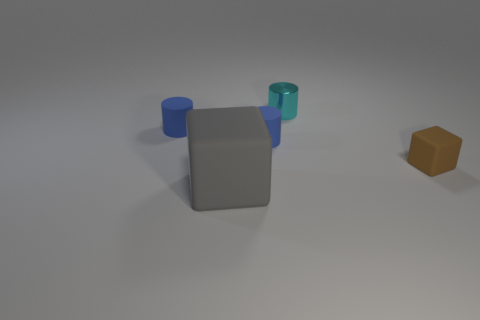Are there any blue cylinders that have the same size as the brown object?
Ensure brevity in your answer.  Yes. There is a object on the left side of the big gray object; is its color the same as the rubber cylinder that is on the right side of the gray matte object?
Keep it short and to the point. Yes. What number of matte objects are small brown spheres or tiny blue cylinders?
Offer a terse response. 2. There is a block that is left of the blue matte object to the right of the big gray rubber object; what number of gray rubber cubes are in front of it?
Your answer should be very brief. 0. What size is the gray object that is made of the same material as the tiny brown thing?
Offer a terse response. Large. There is a blue matte thing that is right of the gray rubber thing; is it the same size as the metal thing?
Offer a very short reply. Yes. What color is the matte object that is right of the gray cube and behind the brown object?
Offer a terse response. Blue. What number of objects are small metallic spheres or blue rubber cylinders left of the gray block?
Give a very brief answer. 1. There is a cube that is in front of the rubber object to the right of the tiny metallic cylinder that is on the right side of the large rubber object; what is its material?
Offer a very short reply. Rubber. Is there anything else that has the same material as the tiny cyan thing?
Your response must be concise. No. 